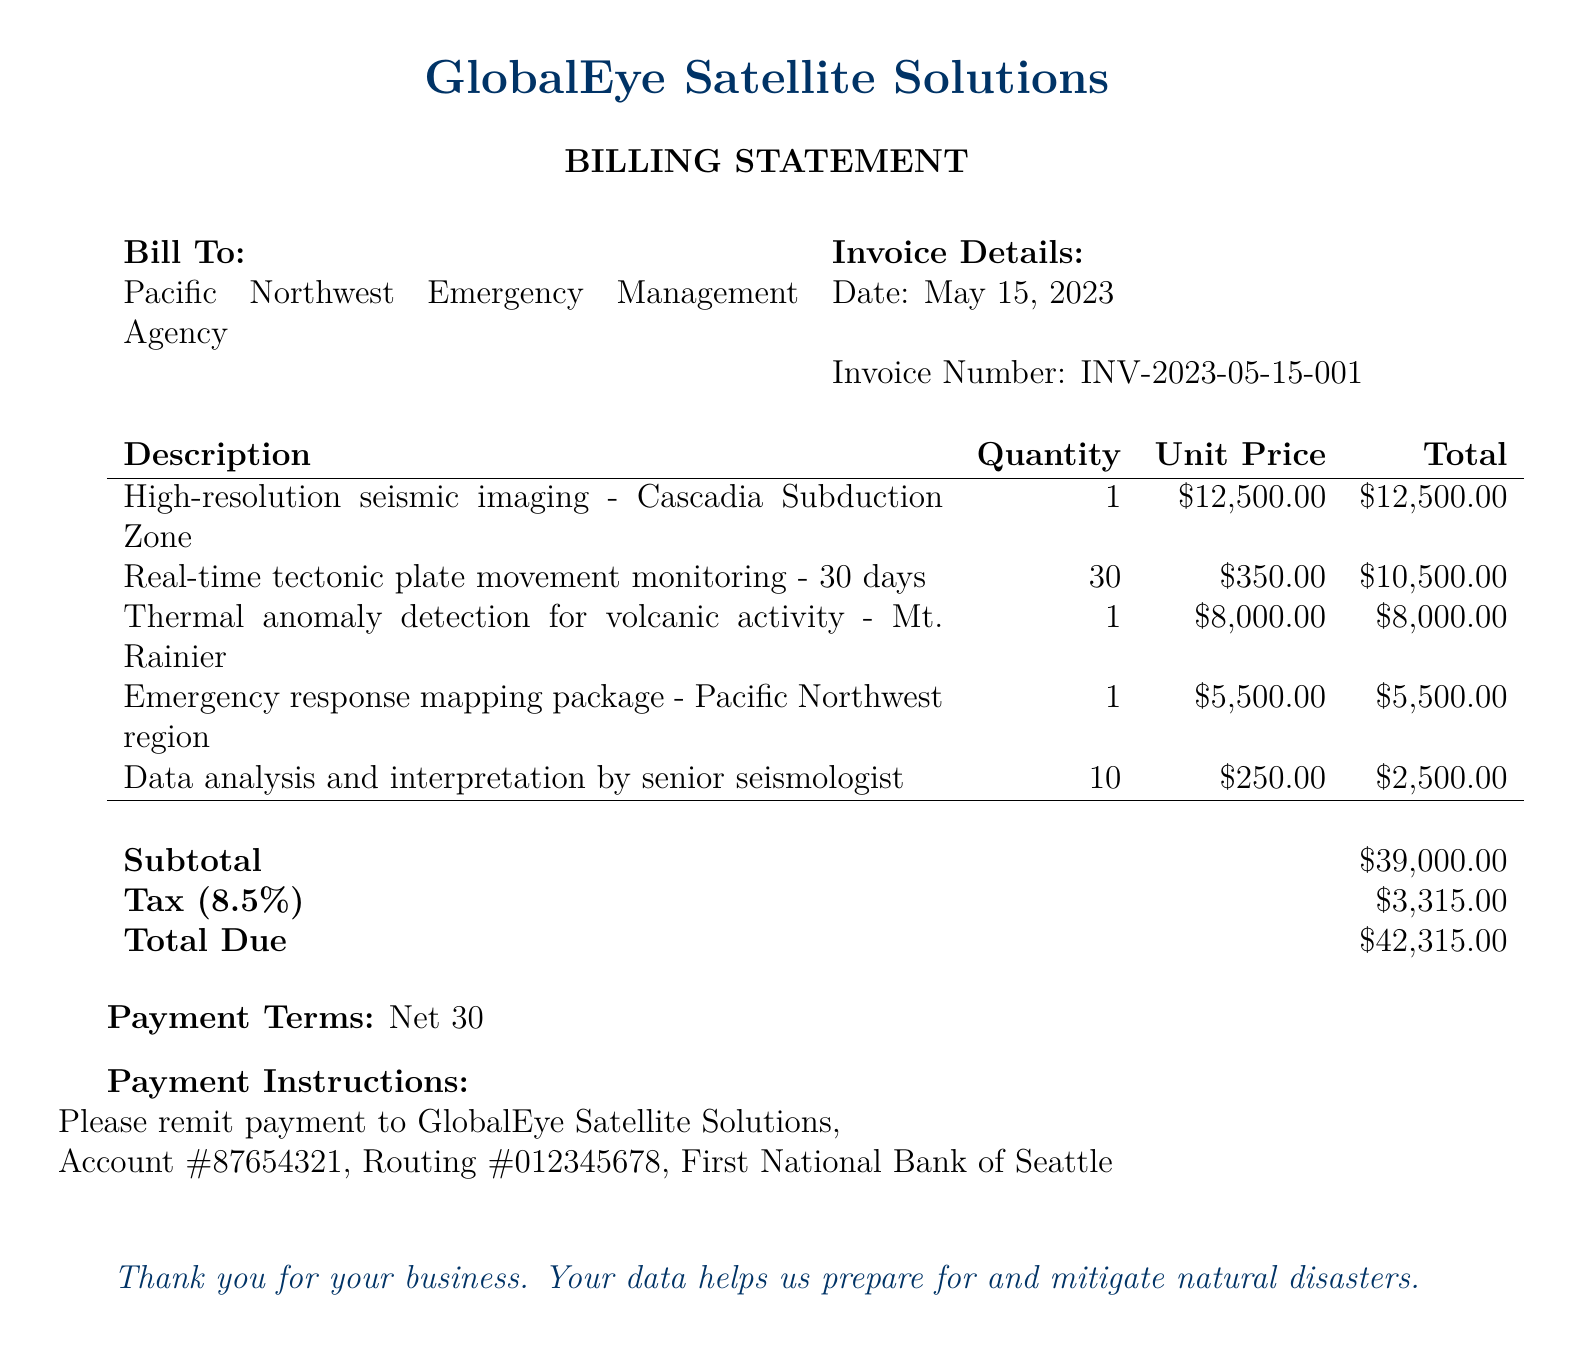What is the date of the invoice? The invoice date is clearly stated in the document under "Invoice Details."
Answer: May 15, 2023 What is the total amount due? The total due is calculated at the bottom of the billing statement.
Answer: $42,315.00 Who is the billing statement addressed to? The name of the organization to whom the bill is addressed is specified in the "Bill To:" section.
Answer: Pacific Northwest Emergency Management Agency What is the tax percentage applied? The tax percentage is mentioned alongside the subtotal and total due.
Answer: 8.5% How many days of real-time tectonic plate movement monitoring were billed? The quantity for the service provided is noted in the description section of the bill.
Answer: 30 What is the unit price for thermal anomaly detection? The unit price is found in the table detailing the services provided.
Answer: $8,000.00 What is the subtotal before tax? The subtotal is specifically mentioned before calculating the tax.
Answer: $39,000.00 How many hours of data analysis and interpretation were billed? The quantity of hours billed for this service is included in the billing details.
Answer: 10 What are the payment terms specified in the document? The payment terms are stated clearly at the bottom of the document.
Answer: Net 30 